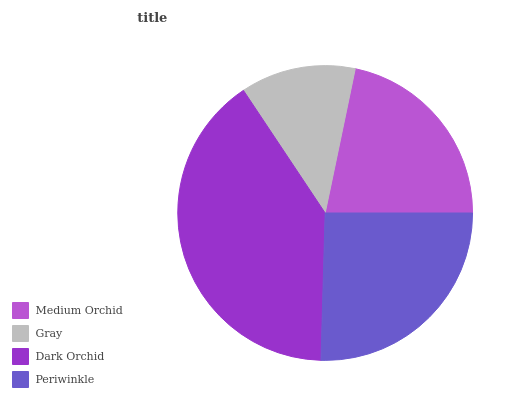Is Gray the minimum?
Answer yes or no. Yes. Is Dark Orchid the maximum?
Answer yes or no. Yes. Is Dark Orchid the minimum?
Answer yes or no. No. Is Gray the maximum?
Answer yes or no. No. Is Dark Orchid greater than Gray?
Answer yes or no. Yes. Is Gray less than Dark Orchid?
Answer yes or no. Yes. Is Gray greater than Dark Orchid?
Answer yes or no. No. Is Dark Orchid less than Gray?
Answer yes or no. No. Is Periwinkle the high median?
Answer yes or no. Yes. Is Medium Orchid the low median?
Answer yes or no. Yes. Is Gray the high median?
Answer yes or no. No. Is Dark Orchid the low median?
Answer yes or no. No. 